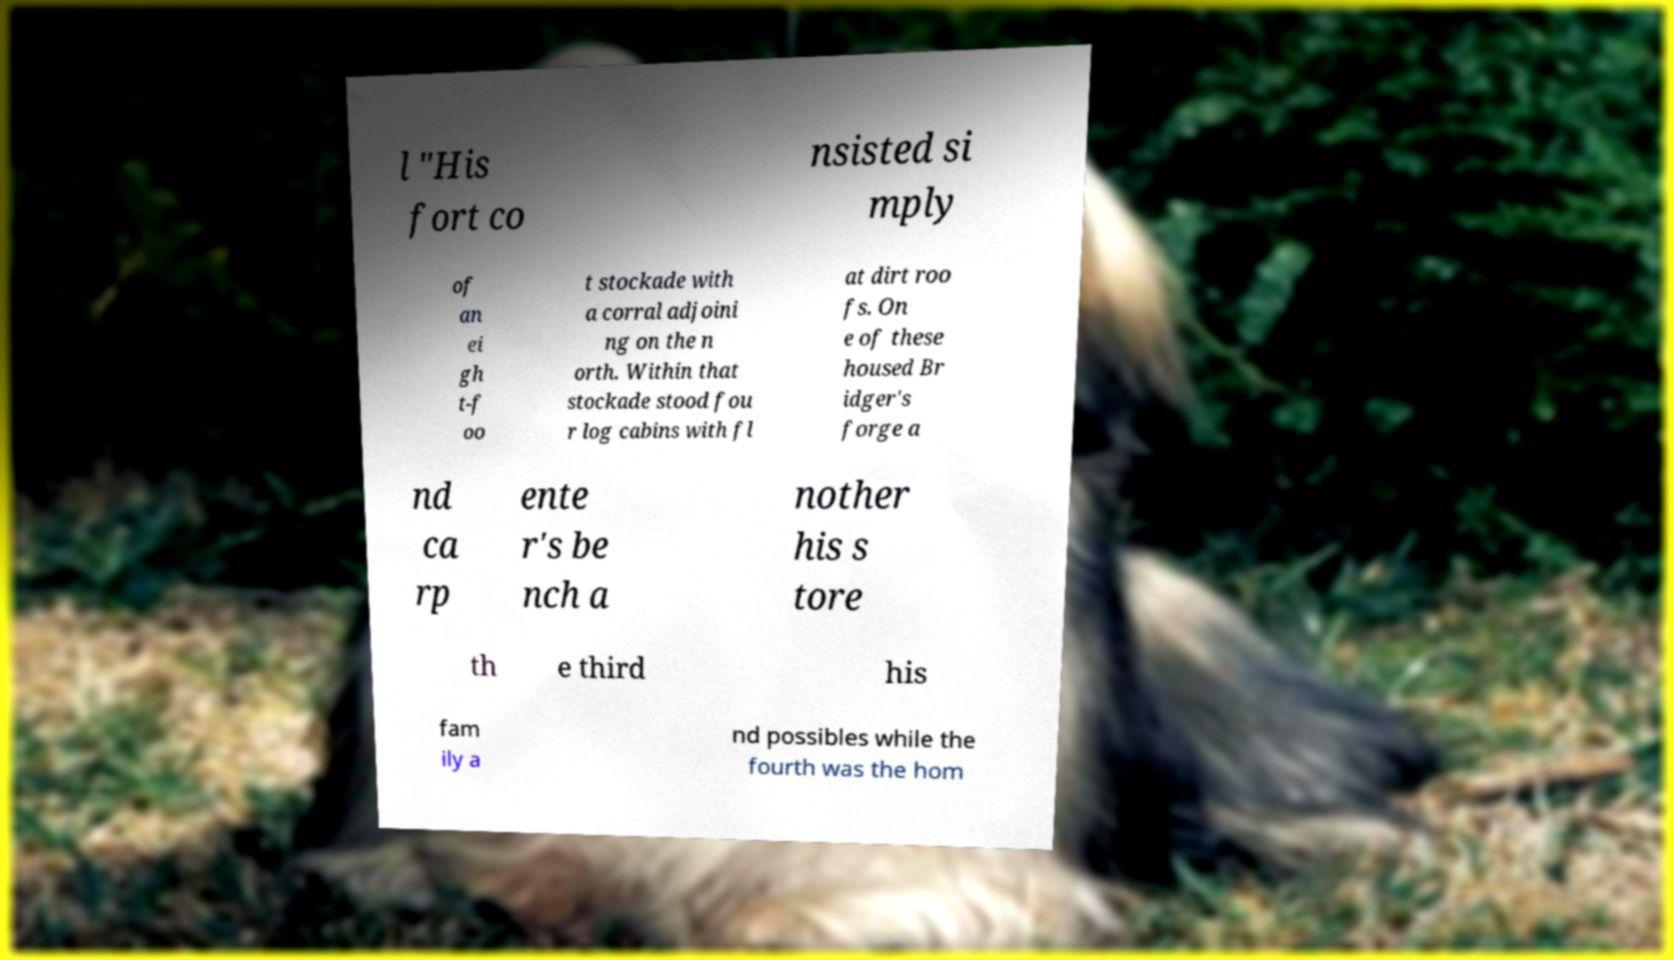Can you read and provide the text displayed in the image?This photo seems to have some interesting text. Can you extract and type it out for me? l "His fort co nsisted si mply of an ei gh t-f oo t stockade with a corral adjoini ng on the n orth. Within that stockade stood fou r log cabins with fl at dirt roo fs. On e of these housed Br idger's forge a nd ca rp ente r's be nch a nother his s tore th e third his fam ily a nd possibles while the fourth was the hom 